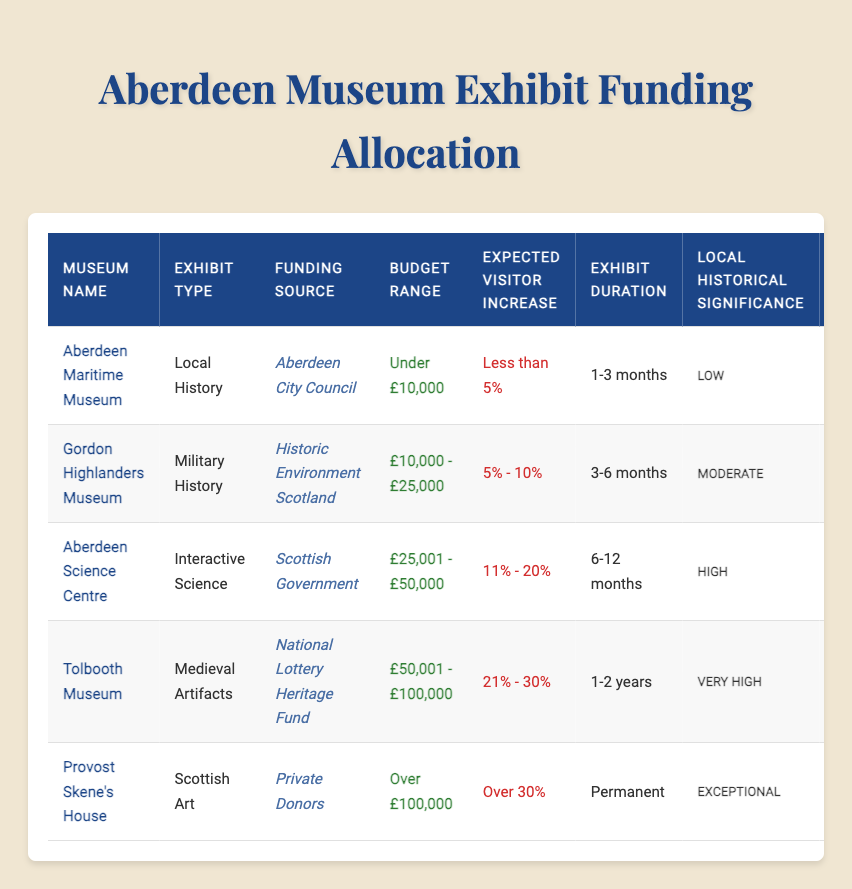What is the funding source for the exhibit at the Gordon Highlanders Museum? The table indicates that the funding source for the exhibit at the Gordon Highlanders Museum is Historic Environment Scotland.
Answer: Historic Environment Scotland Which exhibit has the highest local historical significance? By reviewing the 'Local Historical Significance' column, Provost Skene's House ranks as the highest, with an exceptional designation.
Answer: Provost Skene's House How many exhibits have a budget range of over £50,000? The table lists Tolbooth Museum and Provost Skene's House, which have budget ranges of £50,001 - £100,000 and over £100,000, respectively. Hence, there are two exhibits.
Answer: 2 Is the Aberdeen Science Centre expected to see a visitor increase of over 20%? The expected visitor increase for the Aberdeen Science Centre is 11% - 20%, therefore it is not expected to exceed 20%.
Answer: No Which exhibit type has the lowest expected visitor increase? Looking through the ‘Expected Visitor Increase’ column, the Aberdeen Maritime Museum has the lowest category, which is less than 5%.
Answer: Local History What is the average budget range of the exhibits that are funded by the National Lottery Heritage Fund? The only exhibit funded by the National Lottery Heritage Fund is the Tolbooth Museum, which has a budget range of £50,001 - £100,000. Since there's only one exhibit, the average is the same as that single budget range.
Answer: £50,001 - £100,000 Which museum's exhibit lasts the longest, and for how long? The exhibit at Provost Skene's House is marked as permanent, indicating the longest duration of all the museums listed in the table.
Answer: Provost Skene's House; Permanent Are there any exhibits with minimal Scottish cultural relevance? The table shows that both the Aberdeen Maritime Museum and the Gordon Highlanders Museum have a cultural relevance classified as minimal. Thus, there are exhibits with minimal significance.
Answer: Yes What is the total number of exhibits that expect a visitor increase of 21% or more? The table displays two entries, Tolbooth Museum with 21% - 30% and Provost Skene's House with over 30%. Adding these together, the total count is two exhibits.
Answer: 2 